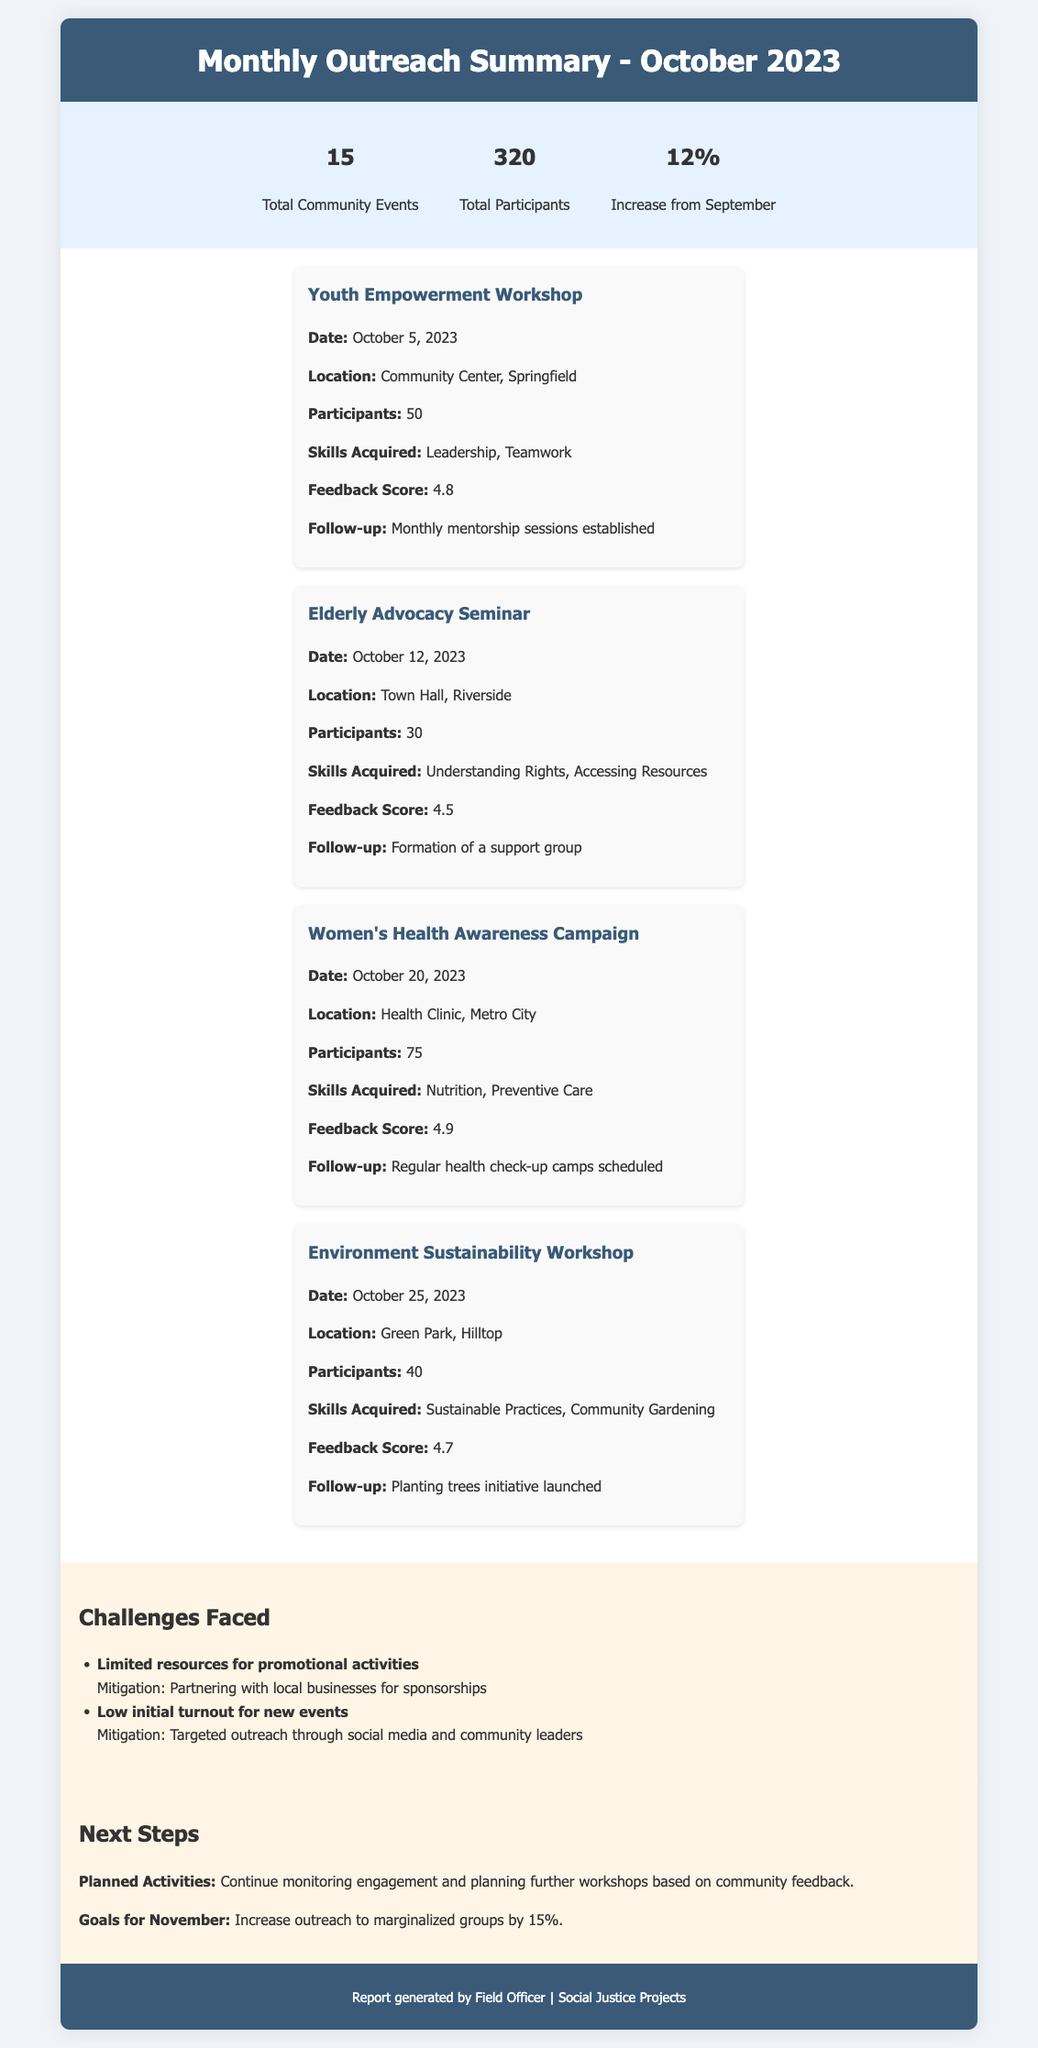What is the total number of community events? The total number of community events is stated directly in the summary section of the document.
Answer: 15 How many total participants attended the events? The total number of participants is provided in the summary section of the document.
Answer: 320 What was the feedback score for the Women's Health Awareness Campaign? The feedback score is listed under the specific activity card for the Women's Health Awareness Campaign.
Answer: 4.9 What skills were acquired in the Youth Empowerment Workshop? The skills acquired are mentioned specifically in the description of the Youth Empowerment Workshop activity.
Answer: Leadership, Teamwork What follow-up action was established after the Elderly Advocacy Seminar? The follow-up action is noted in the Elderly Advocacy Seminar activity card.
Answer: Formation of a support group What percentage is the increase from September? The increase from September is provided in the summary section of the document.
Answer: 12% What is one of the challenges faced during the outreach activities? The challenges are listed in the challenges section of the document, providing specific issues encountered.
Answer: Limited resources for promotional activities What is the goal for November? The goal for November is mentioned in the next steps section, outlining the focus for the upcoming month.
Answer: Increase outreach to marginalized groups by 15% 